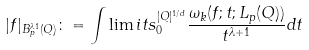<formula> <loc_0><loc_0><loc_500><loc_500>| f | _ { B _ { p } ^ { \lambda 1 } ( Q ) } \colon = \int \lim i t s _ { 0 } ^ { | Q | ^ { 1 / d } } \frac { \omega _ { k } ( f ; t ; L _ { p } ( Q ) ) } { t ^ { \lambda + 1 } } d t</formula> 